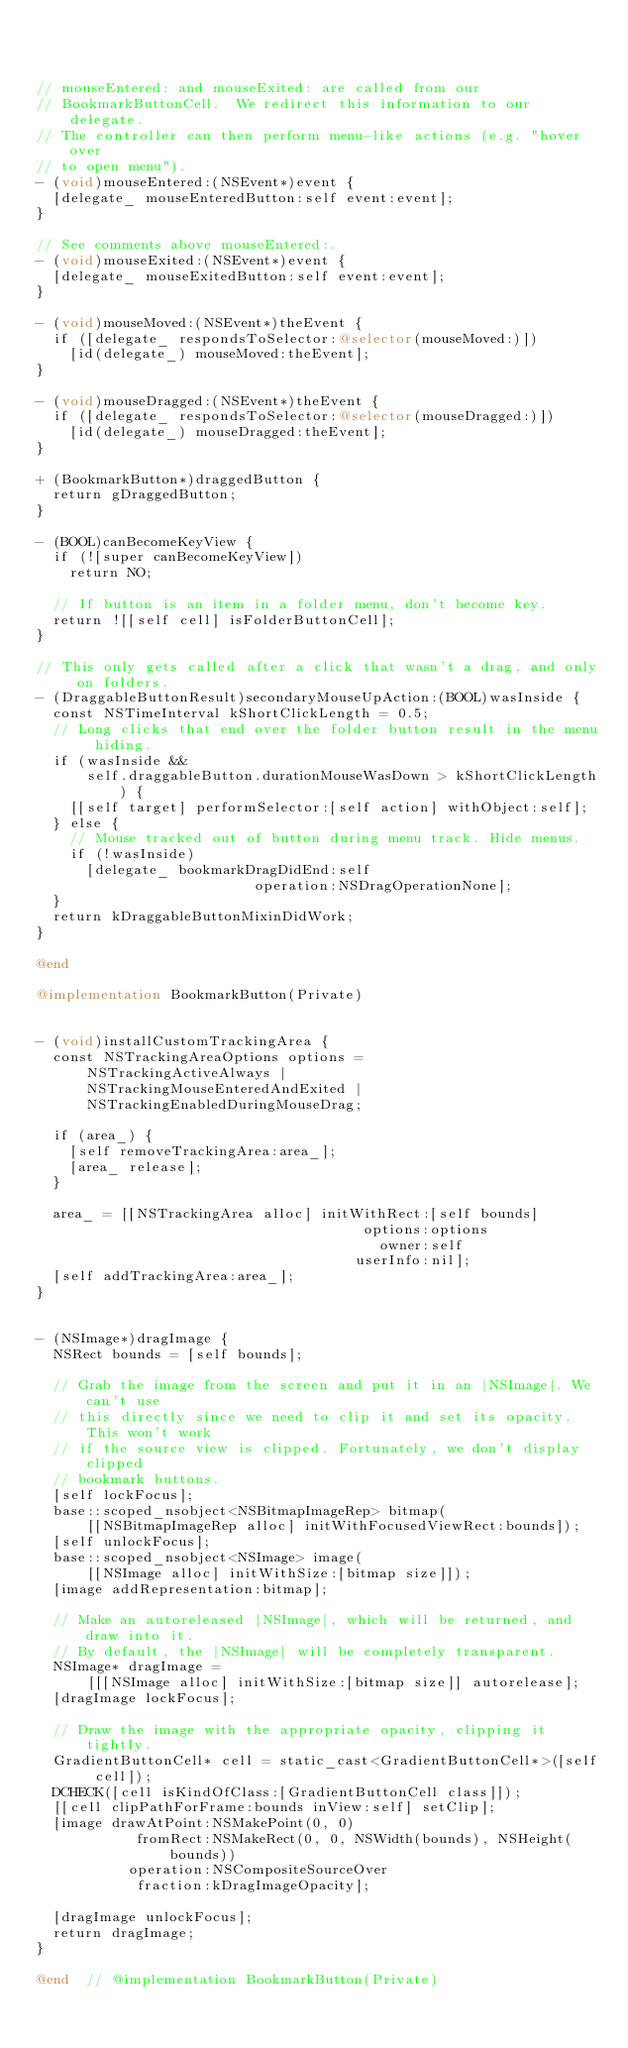<code> <loc_0><loc_0><loc_500><loc_500><_ObjectiveC_>


// mouseEntered: and mouseExited: are called from our
// BookmarkButtonCell.  We redirect this information to our delegate.
// The controller can then perform menu-like actions (e.g. "hover over
// to open menu").
- (void)mouseEntered:(NSEvent*)event {
  [delegate_ mouseEnteredButton:self event:event];
}

// See comments above mouseEntered:.
- (void)mouseExited:(NSEvent*)event {
  [delegate_ mouseExitedButton:self event:event];
}

- (void)mouseMoved:(NSEvent*)theEvent {
  if ([delegate_ respondsToSelector:@selector(mouseMoved:)])
    [id(delegate_) mouseMoved:theEvent];
}

- (void)mouseDragged:(NSEvent*)theEvent {
  if ([delegate_ respondsToSelector:@selector(mouseDragged:)])
    [id(delegate_) mouseDragged:theEvent];
}

+ (BookmarkButton*)draggedButton {
  return gDraggedButton;
}

- (BOOL)canBecomeKeyView {
  if (![super canBecomeKeyView])
    return NO;

  // If button is an item in a folder menu, don't become key.
  return ![[self cell] isFolderButtonCell];
}

// This only gets called after a click that wasn't a drag, and only on folders.
- (DraggableButtonResult)secondaryMouseUpAction:(BOOL)wasInside {
  const NSTimeInterval kShortClickLength = 0.5;
  // Long clicks that end over the folder button result in the menu hiding.
  if (wasInside &&
      self.draggableButton.durationMouseWasDown > kShortClickLength) {
    [[self target] performSelector:[self action] withObject:self];
  } else {
    // Mouse tracked out of button during menu track. Hide menus.
    if (!wasInside)
      [delegate_ bookmarkDragDidEnd:self
                          operation:NSDragOperationNone];
  }
  return kDraggableButtonMixinDidWork;
}

@end

@implementation BookmarkButton(Private)


- (void)installCustomTrackingArea {
  const NSTrackingAreaOptions options =
      NSTrackingActiveAlways |
      NSTrackingMouseEnteredAndExited |
      NSTrackingEnabledDuringMouseDrag;

  if (area_) {
    [self removeTrackingArea:area_];
    [area_ release];
  }

  area_ = [[NSTrackingArea alloc] initWithRect:[self bounds]
                                       options:options
                                         owner:self
                                      userInfo:nil];
  [self addTrackingArea:area_];
}


- (NSImage*)dragImage {
  NSRect bounds = [self bounds];

  // Grab the image from the screen and put it in an |NSImage|. We can't use
  // this directly since we need to clip it and set its opacity. This won't work
  // if the source view is clipped. Fortunately, we don't display clipped
  // bookmark buttons.
  [self lockFocus];
  base::scoped_nsobject<NSBitmapImageRep> bitmap(
      [[NSBitmapImageRep alloc] initWithFocusedViewRect:bounds]);
  [self unlockFocus];
  base::scoped_nsobject<NSImage> image(
      [[NSImage alloc] initWithSize:[bitmap size]]);
  [image addRepresentation:bitmap];

  // Make an autoreleased |NSImage|, which will be returned, and draw into it.
  // By default, the |NSImage| will be completely transparent.
  NSImage* dragImage =
      [[[NSImage alloc] initWithSize:[bitmap size]] autorelease];
  [dragImage lockFocus];

  // Draw the image with the appropriate opacity, clipping it tightly.
  GradientButtonCell* cell = static_cast<GradientButtonCell*>([self cell]);
  DCHECK([cell isKindOfClass:[GradientButtonCell class]]);
  [[cell clipPathForFrame:bounds inView:self] setClip];
  [image drawAtPoint:NSMakePoint(0, 0)
            fromRect:NSMakeRect(0, 0, NSWidth(bounds), NSHeight(bounds))
           operation:NSCompositeSourceOver
            fraction:kDragImageOpacity];

  [dragImage unlockFocus];
  return dragImage;
}

@end  // @implementation BookmarkButton(Private)
</code> 